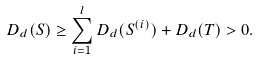Convert formula to latex. <formula><loc_0><loc_0><loc_500><loc_500>D _ { d } ( S ) & \geq \sum _ { i = 1 } ^ { l } D _ { d } ( S ^ { ( i ) } ) + D _ { d } ( T ) > 0 .</formula> 